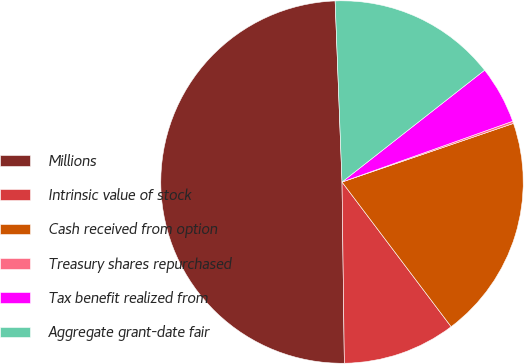Convert chart to OTSL. <chart><loc_0><loc_0><loc_500><loc_500><pie_chart><fcel>Millions<fcel>Intrinsic value of stock<fcel>Cash received from option<fcel>Treasury shares repurchased<fcel>Tax benefit realized from<fcel>Aggregate grant-date fair<nl><fcel>49.6%<fcel>10.08%<fcel>19.96%<fcel>0.2%<fcel>5.14%<fcel>15.02%<nl></chart> 